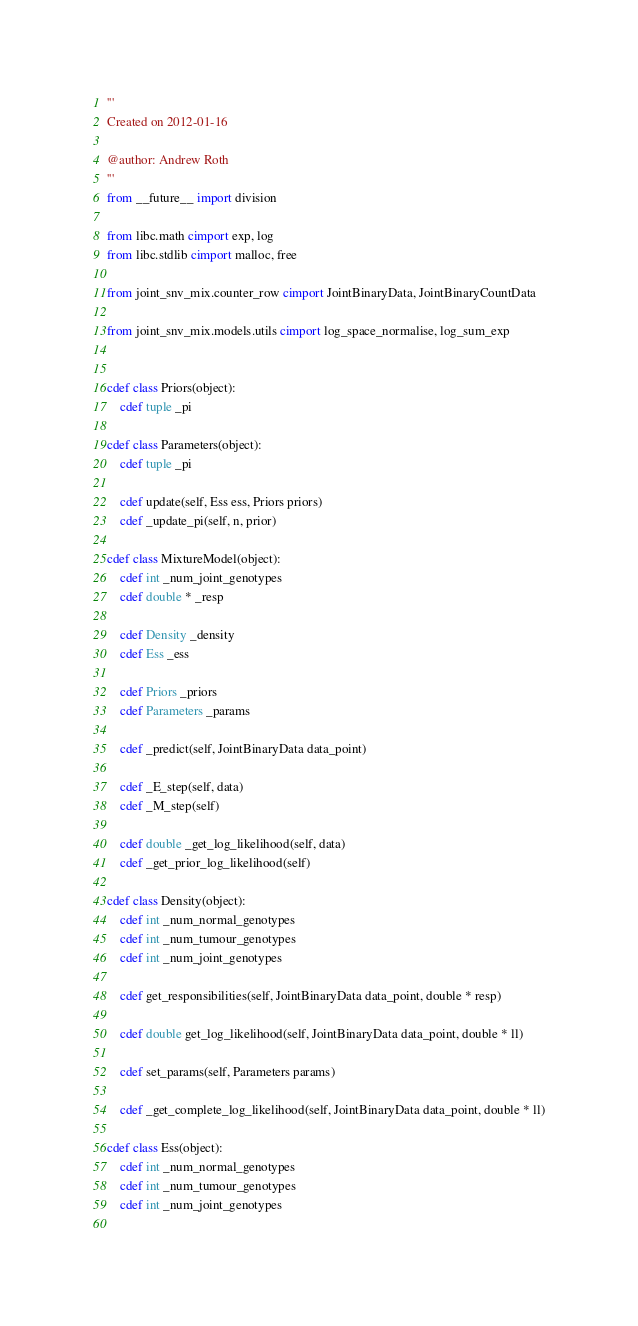Convert code to text. <code><loc_0><loc_0><loc_500><loc_500><_Cython_>'''
Created on 2012-01-16

@author: Andrew Roth
'''
from __future__ import division

from libc.math cimport exp, log
from libc.stdlib cimport malloc, free

from joint_snv_mix.counter_row cimport JointBinaryData, JointBinaryCountData

from joint_snv_mix.models.utils cimport log_space_normalise, log_sum_exp 


cdef class Priors(object):
    cdef tuple _pi
 
cdef class Parameters(object):
    cdef tuple _pi

    cdef update(self, Ess ess, Priors priors)    
    cdef _update_pi(self, n, prior)   

cdef class MixtureModel(object):
    cdef int _num_joint_genotypes    
    cdef double * _resp
    
    cdef Density _density
    cdef Ess _ess
    
    cdef Priors _priors
    cdef Parameters _params

    cdef _predict(self, JointBinaryData data_point)
    
    cdef _E_step(self, data)
    cdef _M_step(self)

    cdef double _get_log_likelihood(self, data)
    cdef _get_prior_log_likelihood(self)
    
cdef class Density(object):  
    cdef int _num_normal_genotypes
    cdef int _num_tumour_genotypes
    cdef int _num_joint_genotypes
     
    cdef get_responsibilities(self, JointBinaryData data_point, double * resp)        
    
    cdef double get_log_likelihood(self, JointBinaryData data_point, double * ll)
        
    cdef set_params(self, Parameters params)    

    cdef _get_complete_log_likelihood(self, JointBinaryData data_point, double * ll)

cdef class Ess(object):
    cdef int _num_normal_genotypes
    cdef int _num_tumour_genotypes
    cdef int _num_joint_genotypes
    </code> 